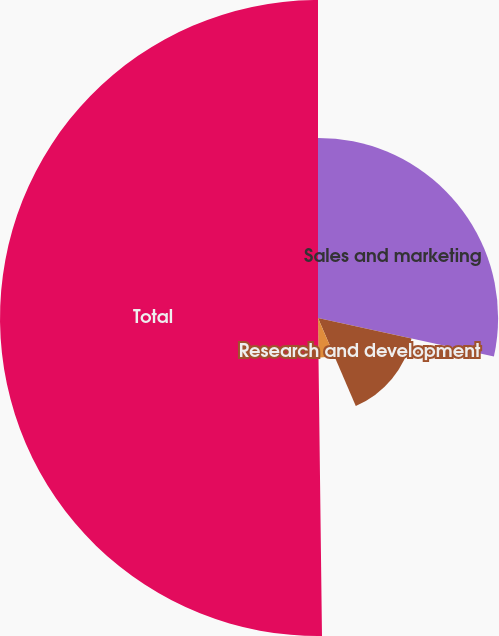Convert chart to OTSL. <chart><loc_0><loc_0><loc_500><loc_500><pie_chart><fcel>Sales and marketing<fcel>Research and development<fcel>General and administrative<fcel>Total<nl><fcel>28.43%<fcel>15.11%<fcel>6.26%<fcel>50.2%<nl></chart> 